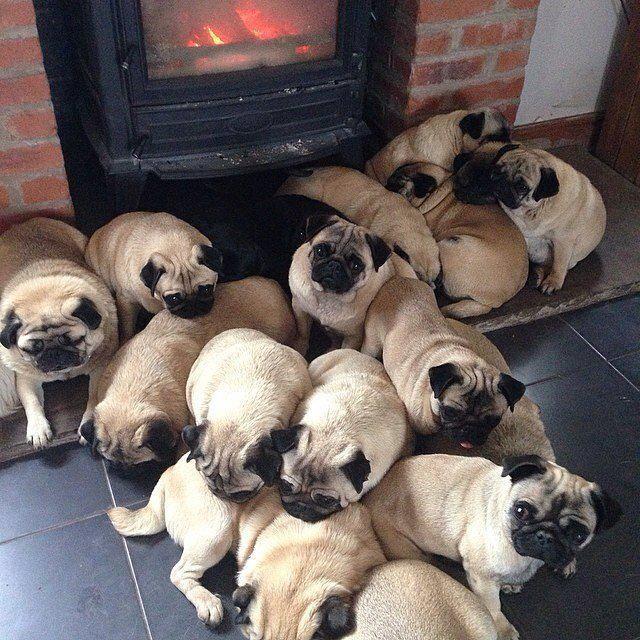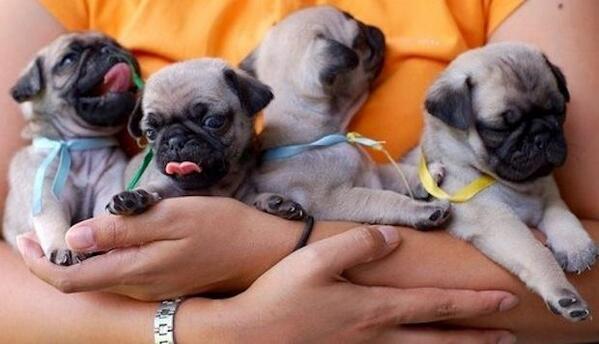The first image is the image on the left, the second image is the image on the right. Evaluate the accuracy of this statement regarding the images: "One picture has exactly three pugs.". Is it true? Answer yes or no. No. 